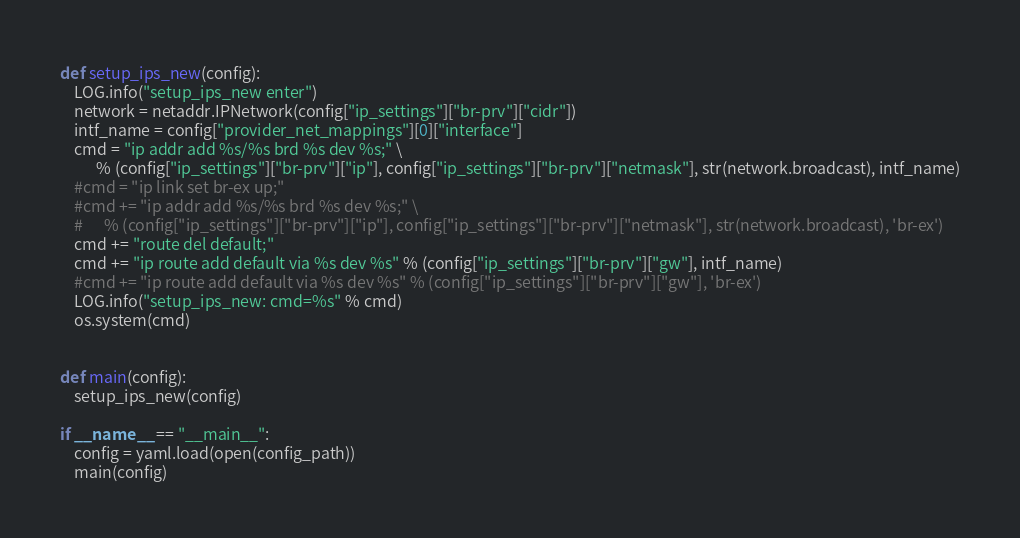<code> <loc_0><loc_0><loc_500><loc_500><_Python_>
def setup_ips_new(config):
    LOG.info("setup_ips_new enter")
    network = netaddr.IPNetwork(config["ip_settings"]["br-prv"]["cidr"])
    intf_name = config["provider_net_mappings"][0]["interface"]
    cmd = "ip addr add %s/%s brd %s dev %s;" \
          % (config["ip_settings"]["br-prv"]["ip"], config["ip_settings"]["br-prv"]["netmask"], str(network.broadcast), intf_name)
    #cmd = "ip link set br-ex up;"
    #cmd += "ip addr add %s/%s brd %s dev %s;" \
    #      % (config["ip_settings"]["br-prv"]["ip"], config["ip_settings"]["br-prv"]["netmask"], str(network.broadcast), 'br-ex')
    cmd += "route del default;"
    cmd += "ip route add default via %s dev %s" % (config["ip_settings"]["br-prv"]["gw"], intf_name)
    #cmd += "ip route add default via %s dev %s" % (config["ip_settings"]["br-prv"]["gw"], 'br-ex')
    LOG.info("setup_ips_new: cmd=%s" % cmd)
    os.system(cmd)


def main(config):
    setup_ips_new(config)    

if __name__ == "__main__":
    config = yaml.load(open(config_path))
    main(config)
</code> 